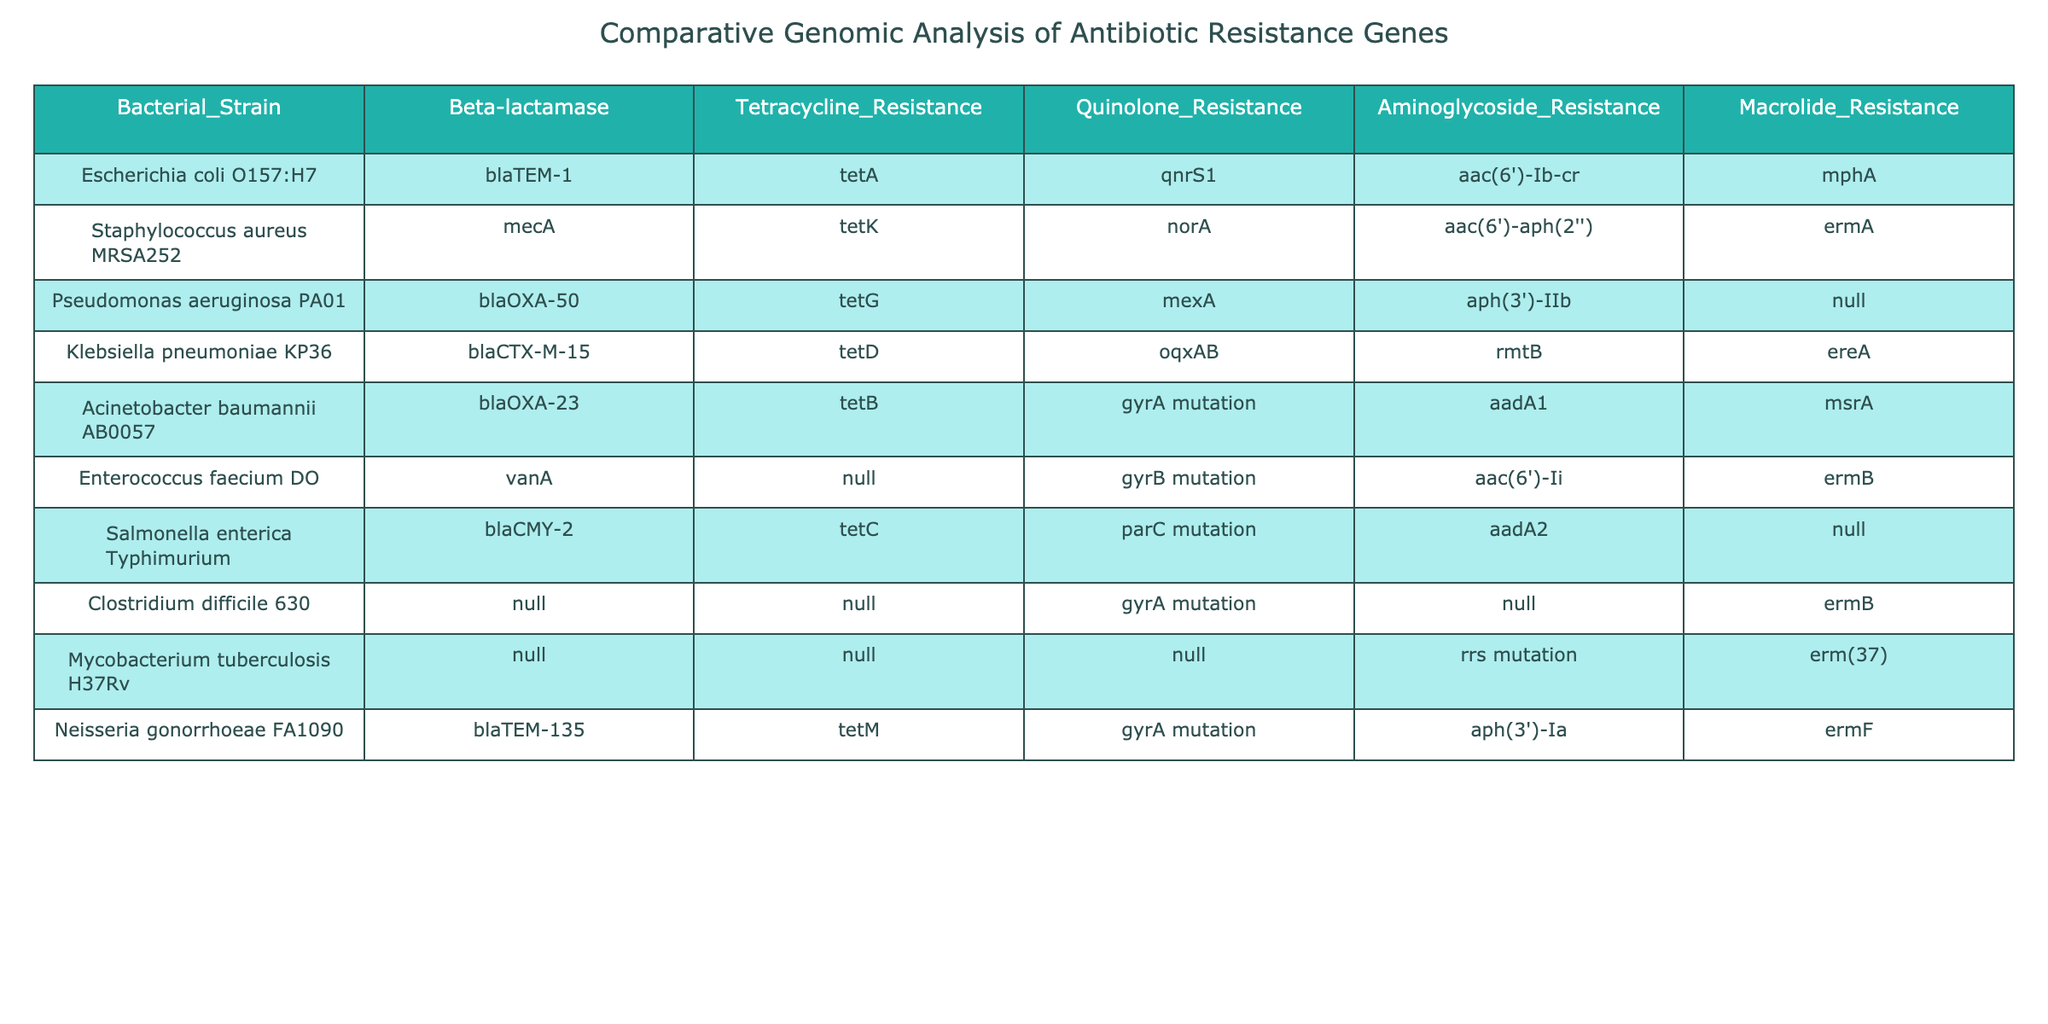What antibiotic resistance gene is found in Escherichia coli O157:H7? The table shows that the antibiotic resistance gene present in Escherichia coli O157:H7 is blaTEM-1 under the Beta-lactamase column.
Answer: blaTEM-1 How many bacterial strains exhibit Tetracycline Resistance? From the table, by counting the entries under the Tetracycline Resistance column, we find that there are six strains listed, which include tetA, tetK, tetG, tetD, tetB, and tetC.
Answer: 6 Is there a bacterial strain that lacks Macrolide Resistance? Checking the Macrolide Resistance column, we see that Pseudomonas aeruginosa PA01 and Salmonella enterica Typhimurium do not have a listed Macrolide Resistance gene. Thus, the statement is true.
Answer: Yes Which resistance gene is most frequently observed across the strains for Aminoglycoside Resistance? By inspecting the Aminoglycoside Resistance column, we see the genes aac(6')-Ib-cr, aac(6')-aph(2''), aph(3')-IIb, rmtB, aadA1, aadA2, and aac(6')-Ii. The aac(6') appears twice, while the others appear once, indicating that aac(6') is the most frequently encountered.
Answer: aac(6') Are there any strains that show both Quinolone Resistance and Macrolide Resistance? In reviewing the table, we find that Pseudomonas aeruginosa PA01 shows Quinolone Resistance with mexA but lacks Macrolide Resistance. Each other strain either lacks Macrolide Resistance or has one or the other, so the answer is false.
Answer: No Which bacterial strain has the most diverse types of resistance genes overall? To determine which strain has the most diverse resistance genes, we need to count the number of resistance genes listed for each strain. For example, Acinetobacter baumannii AB0057 has Beta-lactamase (blaOXA-23), Tetracycline Resistance (tetB), Quinolone Resistance (gyrA mutation), Aminoglycoside Resistance (aadA1), and Macrolide Resistance (msrA), totaling five. This number is higher than the others, indicating that this strain exhibits the most diverse resistance genes.
Answer: Acinetobacter baumannii AB0057 What percentage of strains contain the Quinolone Resistance gene? From our table, there are 10 bacterial strains in total. The Quinolone Resistance has confirmed genes in 5 strains (qnrS1, norA, mexA, oqxAB, and gyrB mutation) and none in 5 strains. To find the percentage, we calculate (5/10)*100 = 50%.
Answer: 50% 